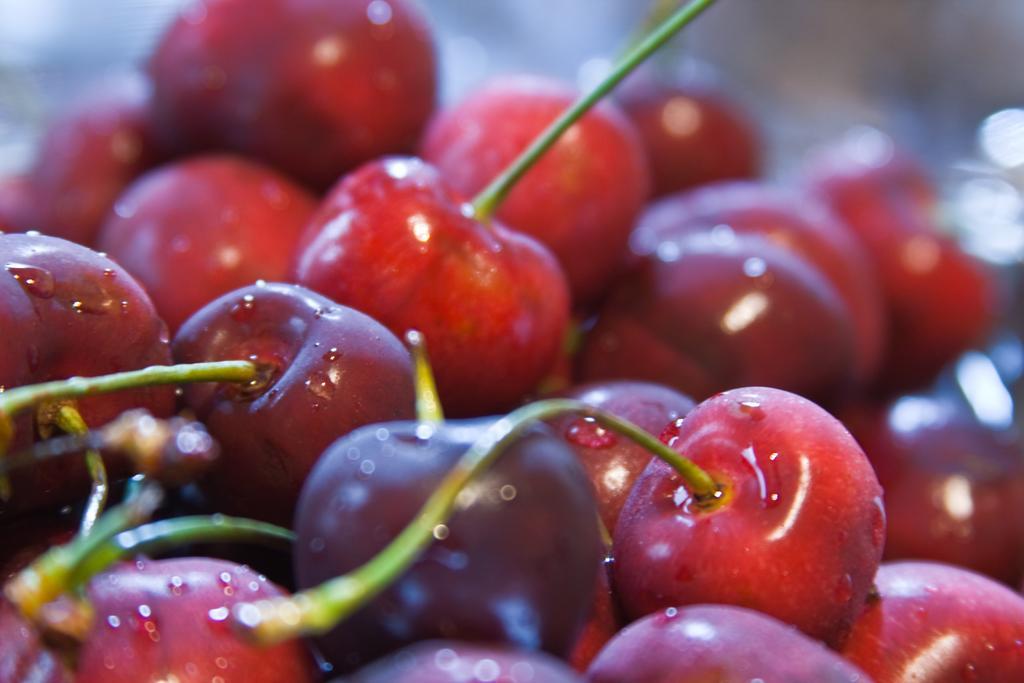Please provide a concise description of this image. In this image, I can see a bunch of cherries. These are the stems, which are green in color. 